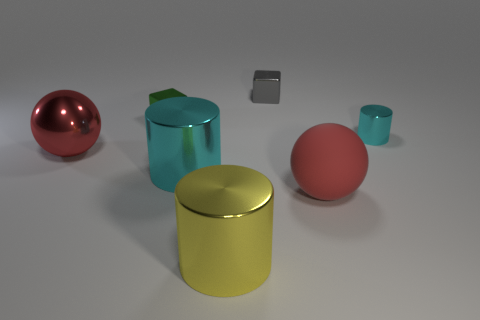Add 1 metallic balls. How many objects exist? 8 Subtract all balls. How many objects are left? 5 Subtract all large cyan shiny things. Subtract all red metallic objects. How many objects are left? 5 Add 7 small metallic cylinders. How many small metallic cylinders are left? 8 Add 5 brown matte things. How many brown matte things exist? 5 Subtract 1 gray blocks. How many objects are left? 6 